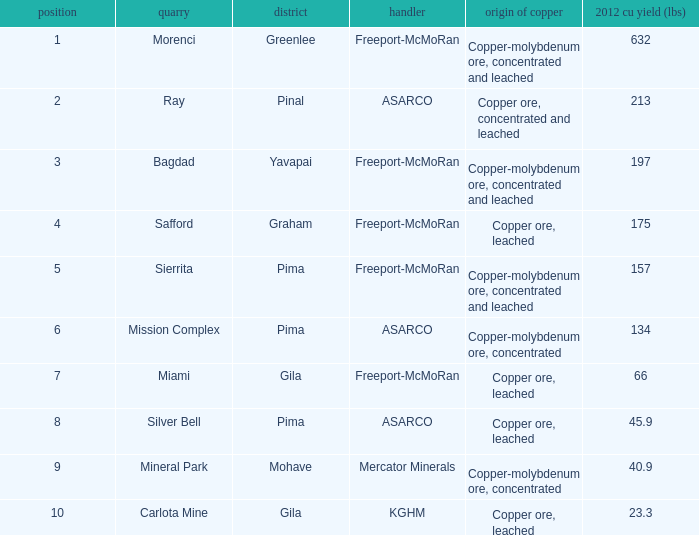What's the lowest ranking source of copper, copper ore, concentrated and leached? 2.0. 